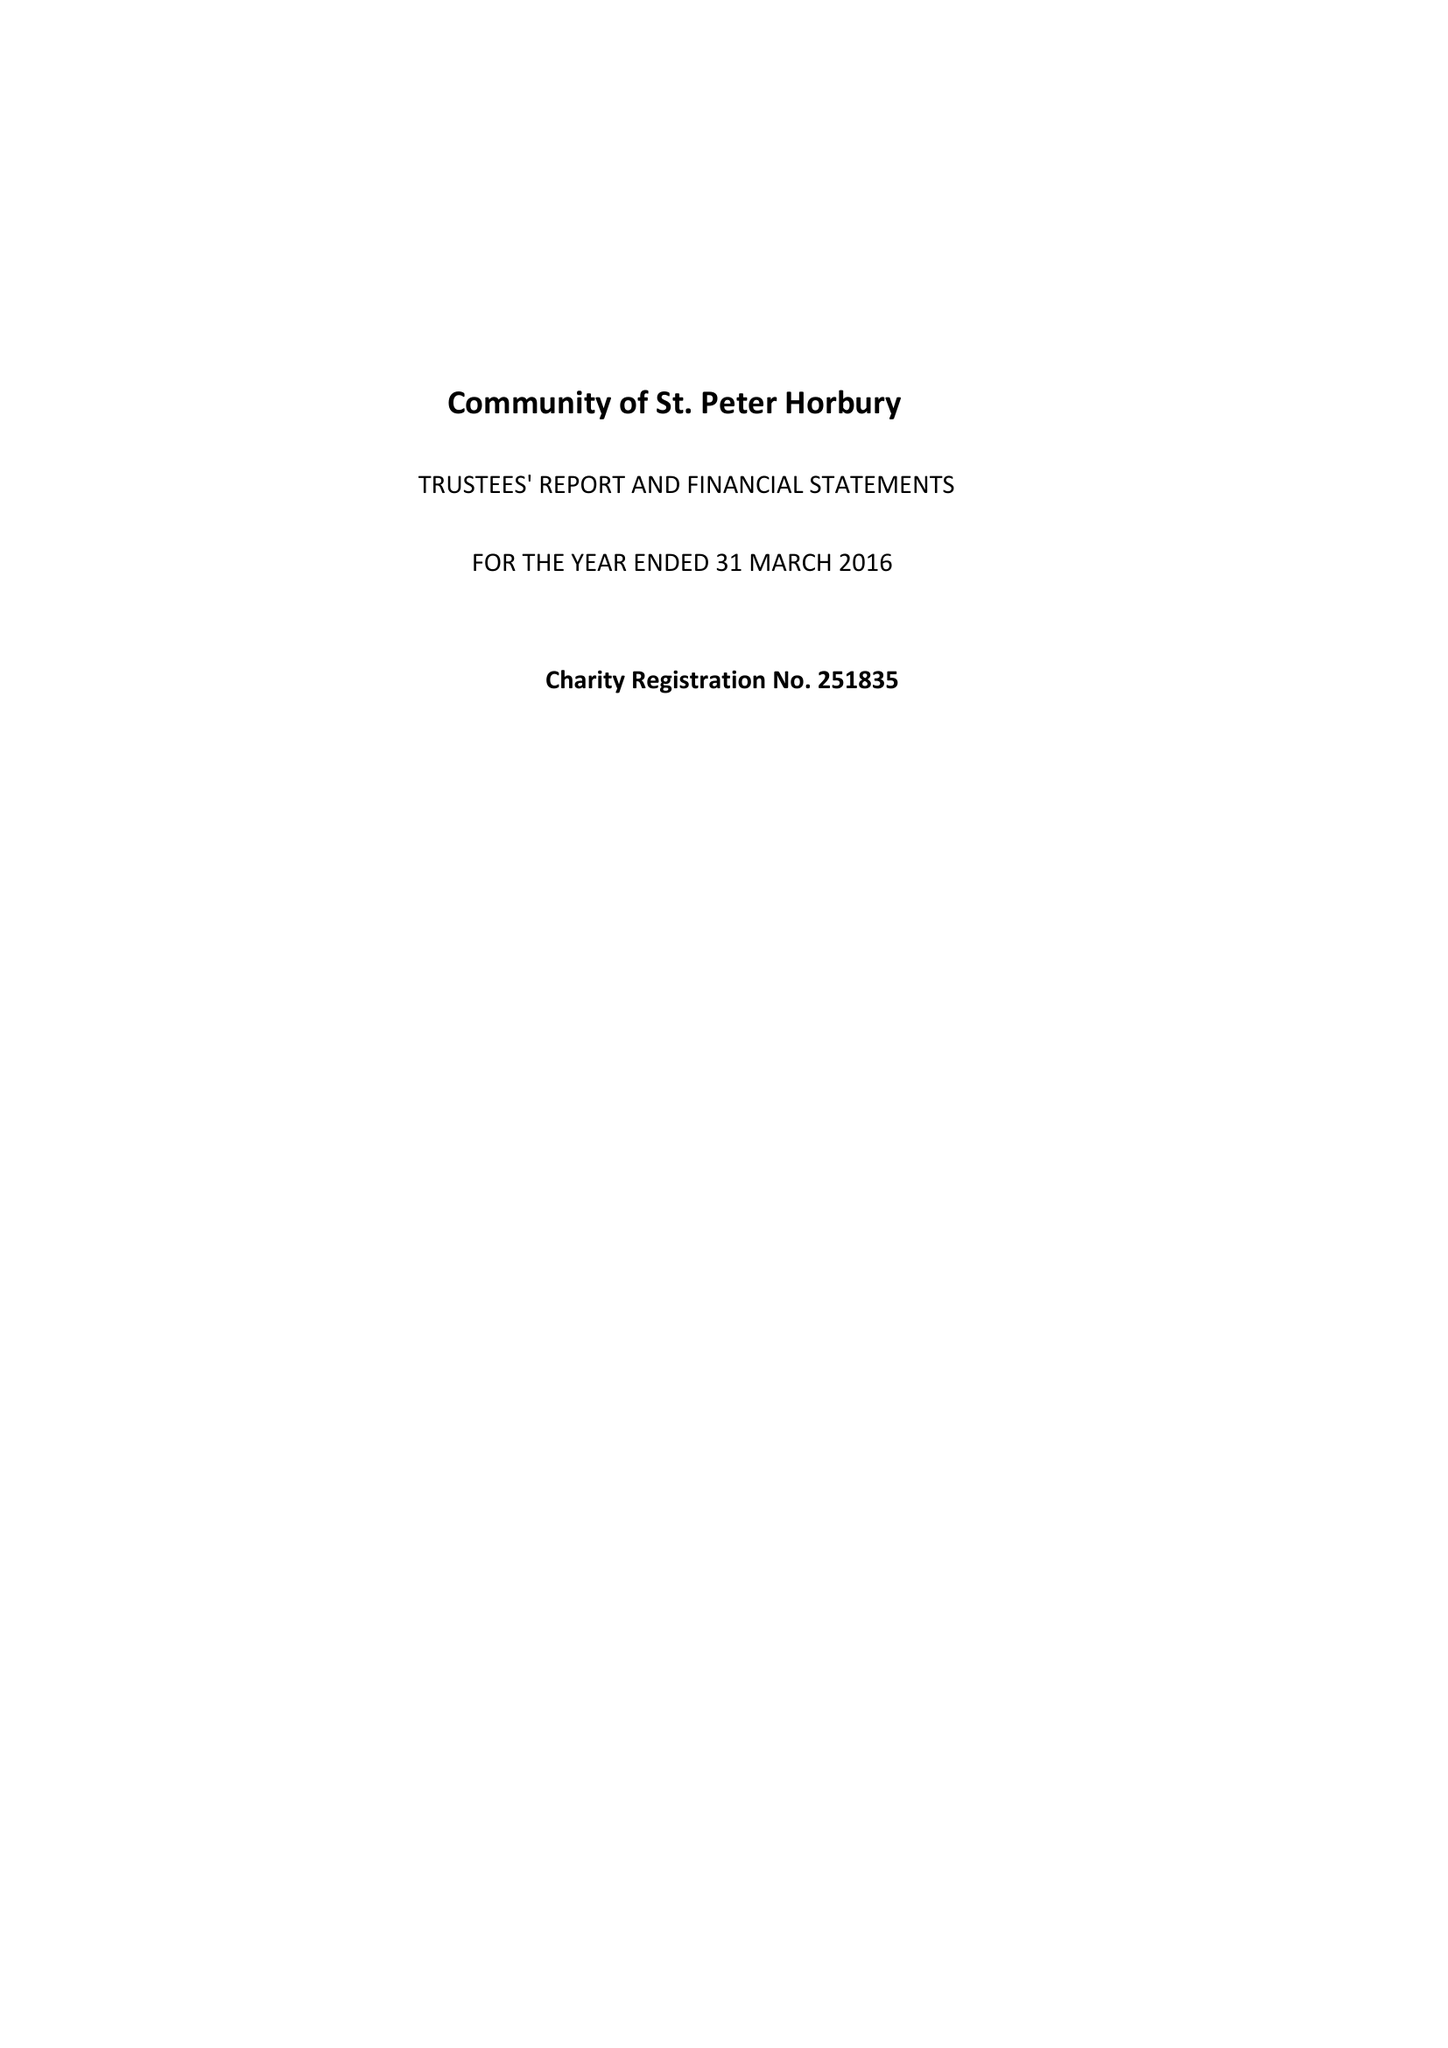What is the value for the charity_name?
Answer the question using a single word or phrase. Community Of St Peter Horbury 